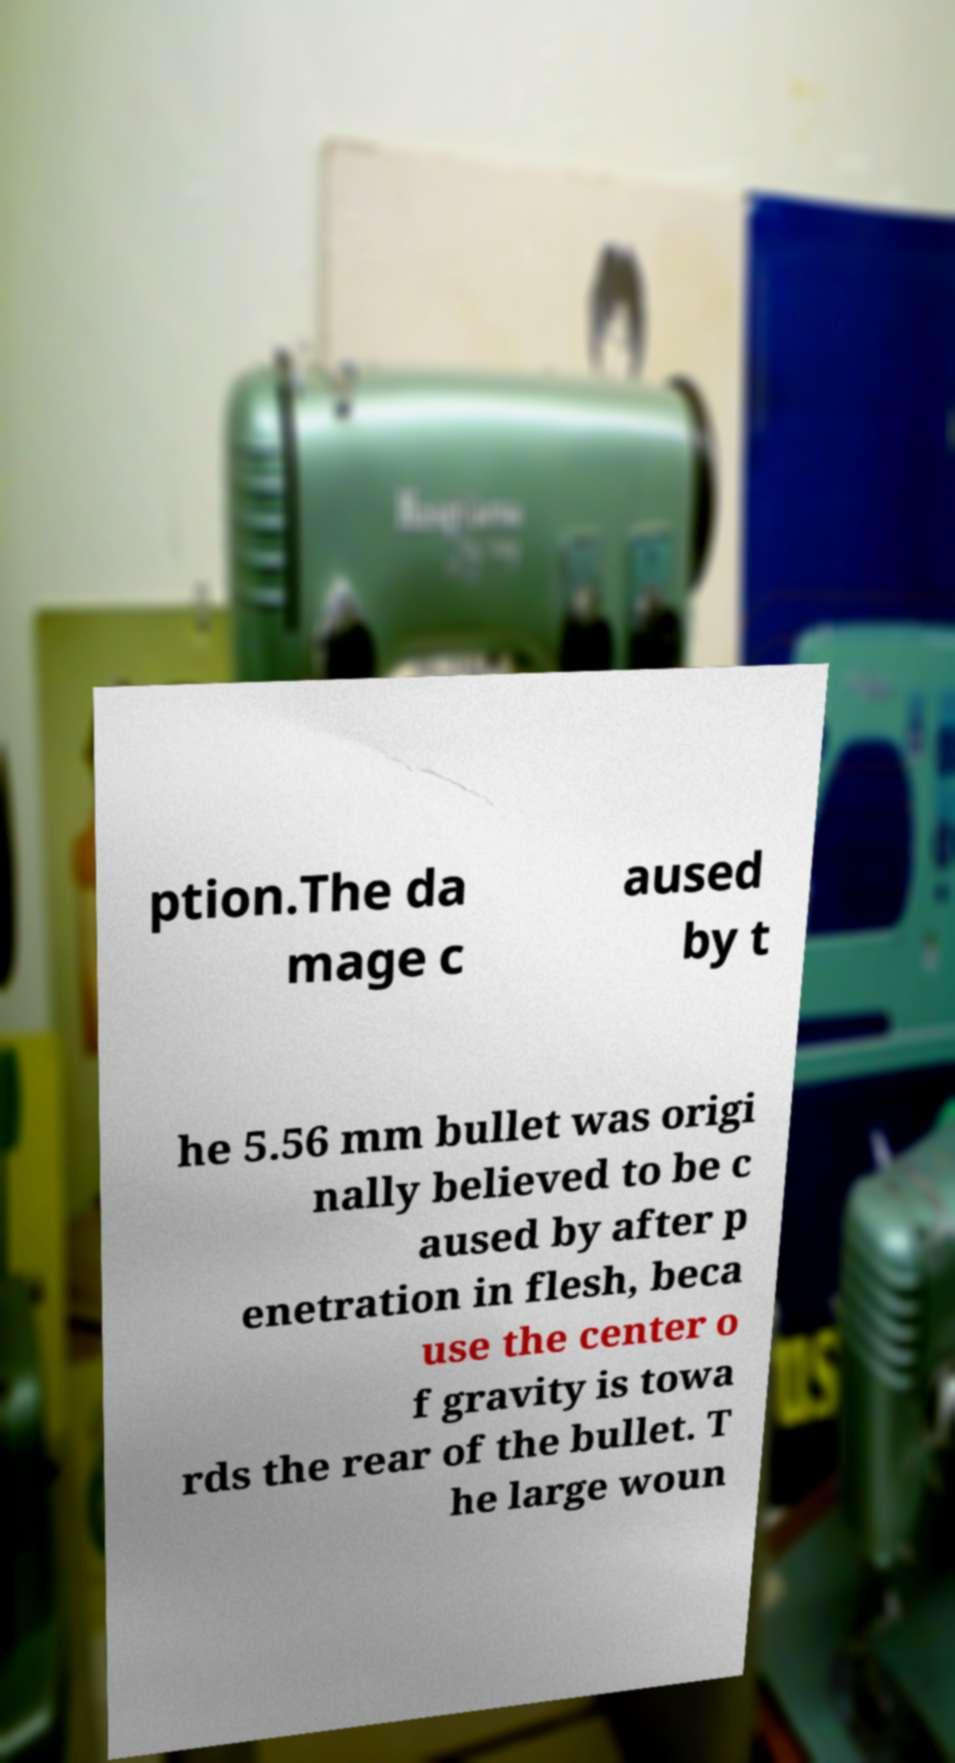There's text embedded in this image that I need extracted. Can you transcribe it verbatim? ption.The da mage c aused by t he 5.56 mm bullet was origi nally believed to be c aused by after p enetration in flesh, beca use the center o f gravity is towa rds the rear of the bullet. T he large woun 